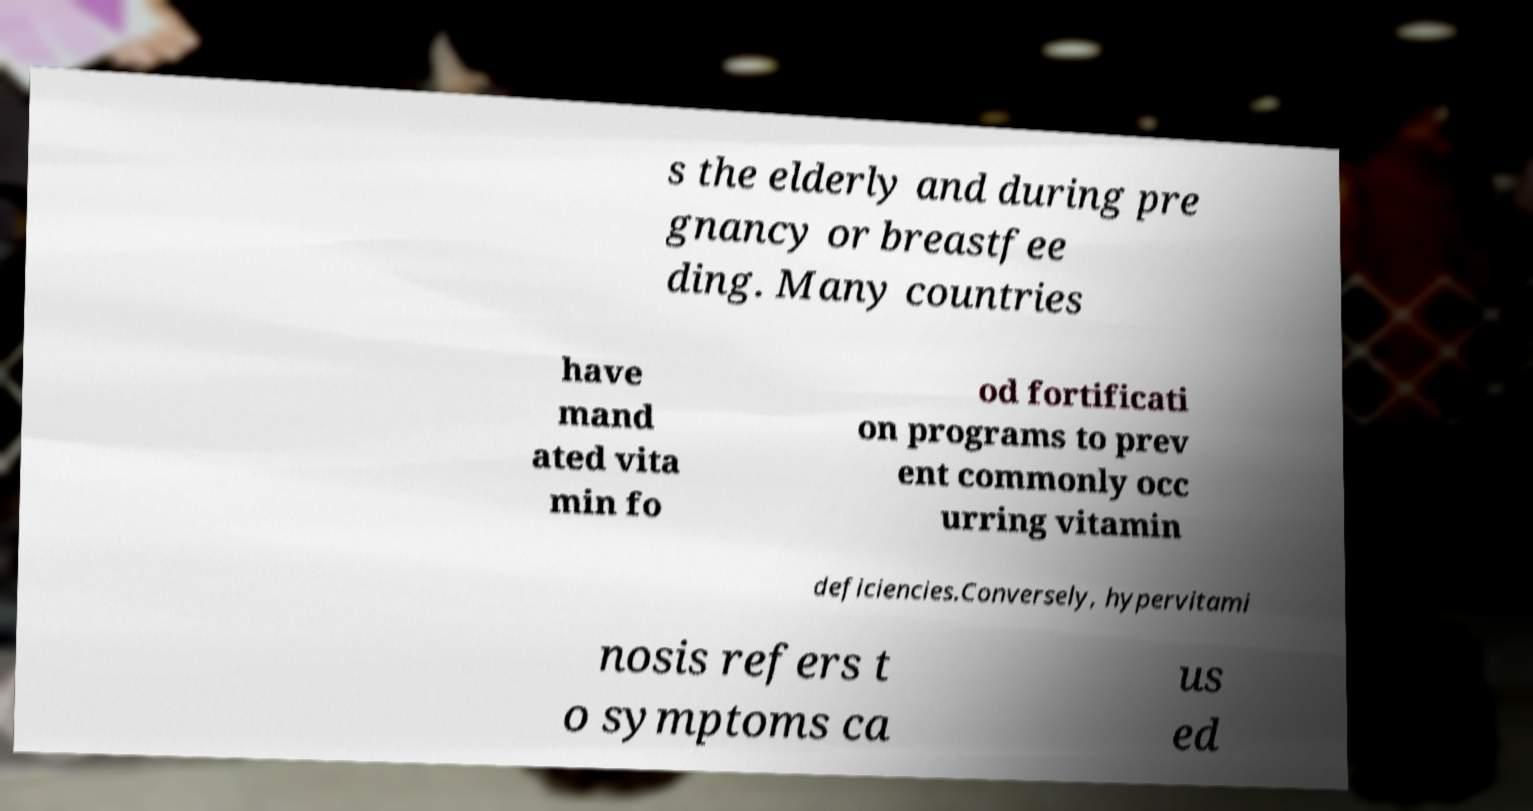For documentation purposes, I need the text within this image transcribed. Could you provide that? s the elderly and during pre gnancy or breastfee ding. Many countries have mand ated vita min fo od fortificati on programs to prev ent commonly occ urring vitamin deficiencies.Conversely, hypervitami nosis refers t o symptoms ca us ed 